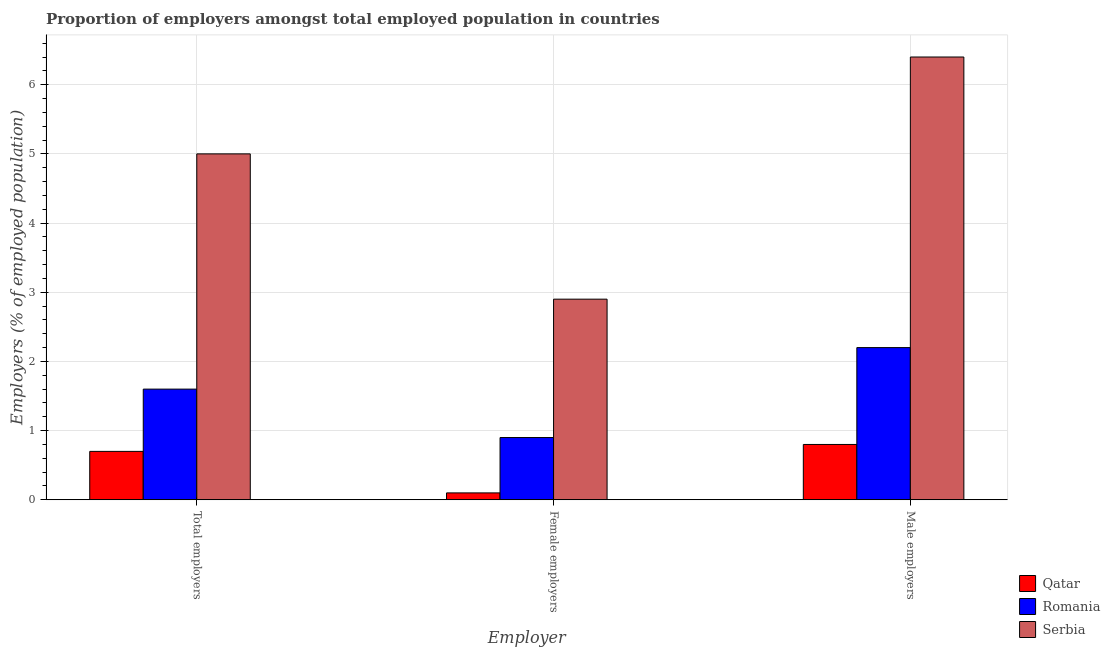How many groups of bars are there?
Your response must be concise. 3. Are the number of bars per tick equal to the number of legend labels?
Offer a terse response. Yes. What is the label of the 2nd group of bars from the left?
Ensure brevity in your answer.  Female employers. What is the percentage of female employers in Romania?
Your answer should be compact. 0.9. Across all countries, what is the maximum percentage of male employers?
Offer a terse response. 6.4. Across all countries, what is the minimum percentage of female employers?
Offer a terse response. 0.1. In which country was the percentage of total employers maximum?
Offer a terse response. Serbia. In which country was the percentage of total employers minimum?
Your answer should be compact. Qatar. What is the total percentage of male employers in the graph?
Provide a succinct answer. 9.4. What is the difference between the percentage of male employers in Serbia and that in Qatar?
Keep it short and to the point. 5.6. What is the difference between the percentage of female employers in Serbia and the percentage of male employers in Qatar?
Make the answer very short. 2.1. What is the average percentage of male employers per country?
Your answer should be very brief. 3.13. What is the difference between the percentage of total employers and percentage of male employers in Qatar?
Provide a short and direct response. -0.1. In how many countries, is the percentage of female employers greater than 0.8 %?
Make the answer very short. 2. What is the ratio of the percentage of male employers in Romania to that in Serbia?
Offer a very short reply. 0.34. Is the percentage of female employers in Romania less than that in Qatar?
Give a very brief answer. No. Is the difference between the percentage of female employers in Qatar and Serbia greater than the difference between the percentage of male employers in Qatar and Serbia?
Offer a very short reply. Yes. What is the difference between the highest and the second highest percentage of female employers?
Offer a very short reply. 2. What is the difference between the highest and the lowest percentage of female employers?
Keep it short and to the point. 2.8. In how many countries, is the percentage of male employers greater than the average percentage of male employers taken over all countries?
Provide a short and direct response. 1. Is the sum of the percentage of female employers in Qatar and Serbia greater than the maximum percentage of total employers across all countries?
Your answer should be compact. No. What does the 3rd bar from the left in Male employers represents?
Your answer should be compact. Serbia. What does the 2nd bar from the right in Female employers represents?
Provide a succinct answer. Romania. How many bars are there?
Provide a short and direct response. 9. Are all the bars in the graph horizontal?
Ensure brevity in your answer.  No. How many countries are there in the graph?
Make the answer very short. 3. What is the difference between two consecutive major ticks on the Y-axis?
Offer a very short reply. 1. Does the graph contain grids?
Provide a succinct answer. Yes. Where does the legend appear in the graph?
Provide a succinct answer. Bottom right. What is the title of the graph?
Ensure brevity in your answer.  Proportion of employers amongst total employed population in countries. Does "Palau" appear as one of the legend labels in the graph?
Your answer should be very brief. No. What is the label or title of the X-axis?
Provide a short and direct response. Employer. What is the label or title of the Y-axis?
Your answer should be compact. Employers (% of employed population). What is the Employers (% of employed population) in Qatar in Total employers?
Your answer should be very brief. 0.7. What is the Employers (% of employed population) in Romania in Total employers?
Your response must be concise. 1.6. What is the Employers (% of employed population) of Qatar in Female employers?
Ensure brevity in your answer.  0.1. What is the Employers (% of employed population) of Romania in Female employers?
Provide a short and direct response. 0.9. What is the Employers (% of employed population) of Serbia in Female employers?
Your answer should be compact. 2.9. What is the Employers (% of employed population) in Qatar in Male employers?
Your response must be concise. 0.8. What is the Employers (% of employed population) of Romania in Male employers?
Offer a very short reply. 2.2. What is the Employers (% of employed population) in Serbia in Male employers?
Give a very brief answer. 6.4. Across all Employer, what is the maximum Employers (% of employed population) of Qatar?
Your answer should be compact. 0.8. Across all Employer, what is the maximum Employers (% of employed population) in Romania?
Keep it short and to the point. 2.2. Across all Employer, what is the maximum Employers (% of employed population) in Serbia?
Provide a short and direct response. 6.4. Across all Employer, what is the minimum Employers (% of employed population) in Qatar?
Ensure brevity in your answer.  0.1. Across all Employer, what is the minimum Employers (% of employed population) of Romania?
Your answer should be compact. 0.9. Across all Employer, what is the minimum Employers (% of employed population) in Serbia?
Give a very brief answer. 2.9. What is the total Employers (% of employed population) of Romania in the graph?
Your answer should be compact. 4.7. What is the difference between the Employers (% of employed population) in Serbia in Total employers and that in Female employers?
Offer a terse response. 2.1. What is the difference between the Employers (% of employed population) of Qatar in Total employers and that in Male employers?
Provide a short and direct response. -0.1. What is the difference between the Employers (% of employed population) of Serbia in Total employers and that in Male employers?
Keep it short and to the point. -1.4. What is the difference between the Employers (% of employed population) of Qatar in Female employers and that in Male employers?
Ensure brevity in your answer.  -0.7. What is the difference between the Employers (% of employed population) in Romania in Female employers and that in Male employers?
Make the answer very short. -1.3. What is the difference between the Employers (% of employed population) of Serbia in Female employers and that in Male employers?
Provide a short and direct response. -3.5. What is the difference between the Employers (% of employed population) of Qatar in Total employers and the Employers (% of employed population) of Romania in Female employers?
Your response must be concise. -0.2. What is the difference between the Employers (% of employed population) in Qatar in Total employers and the Employers (% of employed population) in Serbia in Female employers?
Provide a succinct answer. -2.2. What is the difference between the Employers (% of employed population) of Romania in Total employers and the Employers (% of employed population) of Serbia in Female employers?
Offer a very short reply. -1.3. What is the difference between the Employers (% of employed population) in Qatar in Total employers and the Employers (% of employed population) in Romania in Male employers?
Give a very brief answer. -1.5. What is the difference between the Employers (% of employed population) of Qatar in Total employers and the Employers (% of employed population) of Serbia in Male employers?
Offer a terse response. -5.7. What is the difference between the Employers (% of employed population) in Qatar in Female employers and the Employers (% of employed population) in Romania in Male employers?
Your response must be concise. -2.1. What is the difference between the Employers (% of employed population) of Qatar in Female employers and the Employers (% of employed population) of Serbia in Male employers?
Offer a terse response. -6.3. What is the difference between the Employers (% of employed population) of Romania in Female employers and the Employers (% of employed population) of Serbia in Male employers?
Keep it short and to the point. -5.5. What is the average Employers (% of employed population) in Qatar per Employer?
Your answer should be compact. 0.53. What is the average Employers (% of employed population) of Romania per Employer?
Ensure brevity in your answer.  1.57. What is the average Employers (% of employed population) in Serbia per Employer?
Keep it short and to the point. 4.77. What is the difference between the Employers (% of employed population) of Qatar and Employers (% of employed population) of Romania in Total employers?
Ensure brevity in your answer.  -0.9. What is the difference between the Employers (% of employed population) in Qatar and Employers (% of employed population) in Serbia in Female employers?
Provide a succinct answer. -2.8. What is the ratio of the Employers (% of employed population) of Qatar in Total employers to that in Female employers?
Offer a very short reply. 7. What is the ratio of the Employers (% of employed population) of Romania in Total employers to that in Female employers?
Your answer should be very brief. 1.78. What is the ratio of the Employers (% of employed population) of Serbia in Total employers to that in Female employers?
Give a very brief answer. 1.72. What is the ratio of the Employers (% of employed population) in Qatar in Total employers to that in Male employers?
Offer a terse response. 0.88. What is the ratio of the Employers (% of employed population) of Romania in Total employers to that in Male employers?
Provide a succinct answer. 0.73. What is the ratio of the Employers (% of employed population) of Serbia in Total employers to that in Male employers?
Make the answer very short. 0.78. What is the ratio of the Employers (% of employed population) in Romania in Female employers to that in Male employers?
Your response must be concise. 0.41. What is the ratio of the Employers (% of employed population) of Serbia in Female employers to that in Male employers?
Offer a very short reply. 0.45. What is the difference between the highest and the lowest Employers (% of employed population) of Qatar?
Your answer should be very brief. 0.7. 